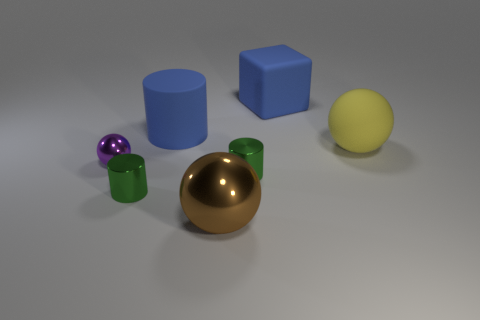Subtract all metallic spheres. How many spheres are left? 1 Add 2 blue rubber cubes. How many objects exist? 9 Subtract all cylinders. How many objects are left? 4 Subtract 3 spheres. How many spheres are left? 0 Subtract all brown cylinders. How many purple spheres are left? 1 Subtract all green shiny cylinders. Subtract all matte objects. How many objects are left? 2 Add 1 big rubber cylinders. How many big rubber cylinders are left? 2 Add 1 large cyan metallic balls. How many large cyan metallic balls exist? 1 Subtract all yellow balls. How many balls are left? 2 Subtract 1 blue cubes. How many objects are left? 6 